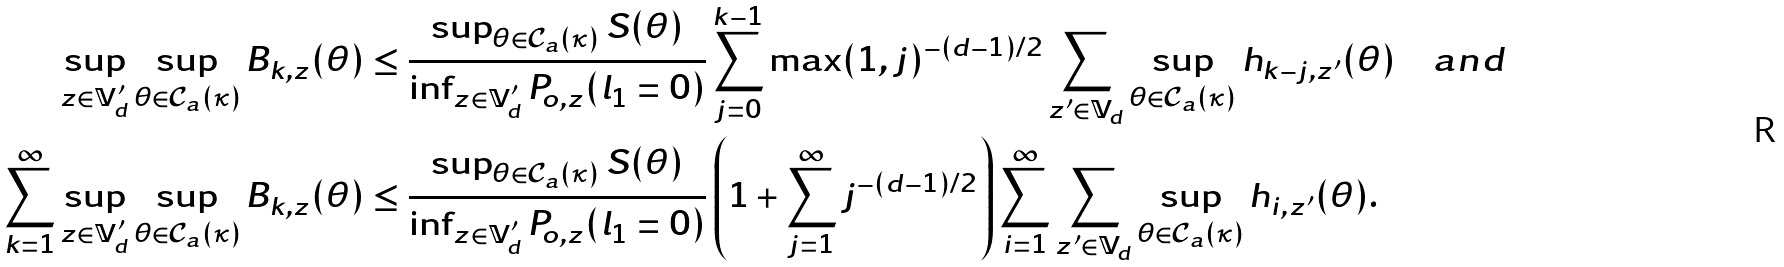<formula> <loc_0><loc_0><loc_500><loc_500>\sup _ { z \in \mathbb { V } _ { d } ^ { \prime } } \sup _ { \theta \in \mathcal { C } _ { a } ( \kappa ) } B _ { k , z } ( \theta ) & \leq \frac { \sup _ { \theta \in \mathcal { C } _ { a } ( \kappa ) } S ( \theta ) } { \inf _ { z \in \mathbb { V } _ { d } ^ { \prime } } P _ { o , z } ( l _ { 1 } = 0 ) } \sum _ { j = 0 } ^ { k - 1 } \max ( 1 , j ) ^ { - ( d - 1 ) / 2 } \sum _ { z ^ { \prime } \in \mathbb { V } _ { d } } \sup _ { \theta \in \mathcal { C } _ { a } ( \kappa ) } h _ { k - j , z ^ { \prime } } ( \theta ) \quad a n d \\ \sum _ { k = 1 } ^ { \infty } \sup _ { z \in \mathbb { V } _ { d } ^ { \prime } } \sup _ { \theta \in \mathcal { C } _ { a } ( \kappa ) } B _ { k , z } ( \theta ) & \leq \frac { \sup _ { \theta \in \mathcal { C } _ { a } ( \kappa ) } S ( \theta ) } { \inf _ { z \in \mathbb { V } _ { d } ^ { \prime } } P _ { o , z } ( l _ { 1 } = 0 ) } \left ( 1 + \sum _ { j = 1 } ^ { \infty } j ^ { - ( d - 1 ) / 2 } \right ) \sum _ { i = 1 } ^ { \infty } \sum _ { z ^ { \prime } \in \mathbb { V } _ { d } } \sup _ { \theta \in \mathcal { C } _ { a } ( \kappa ) } h _ { i , z ^ { \prime } } ( \theta ) .</formula> 